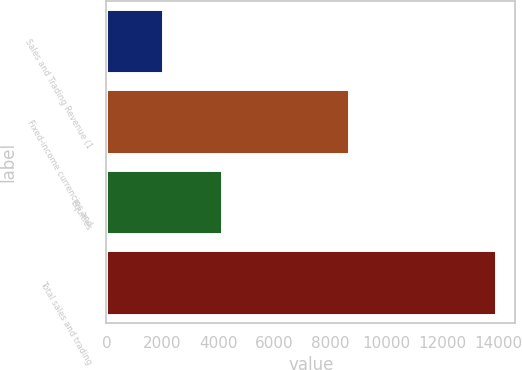Convert chart. <chart><loc_0><loc_0><loc_500><loc_500><bar_chart><fcel>Sales and Trading Revenue (1<fcel>Fixed-income currencies and<fcel>Equities<fcel>Total sales and trading<nl><fcel>2017<fcel>8657<fcel>4120<fcel>13895.8<nl></chart> 